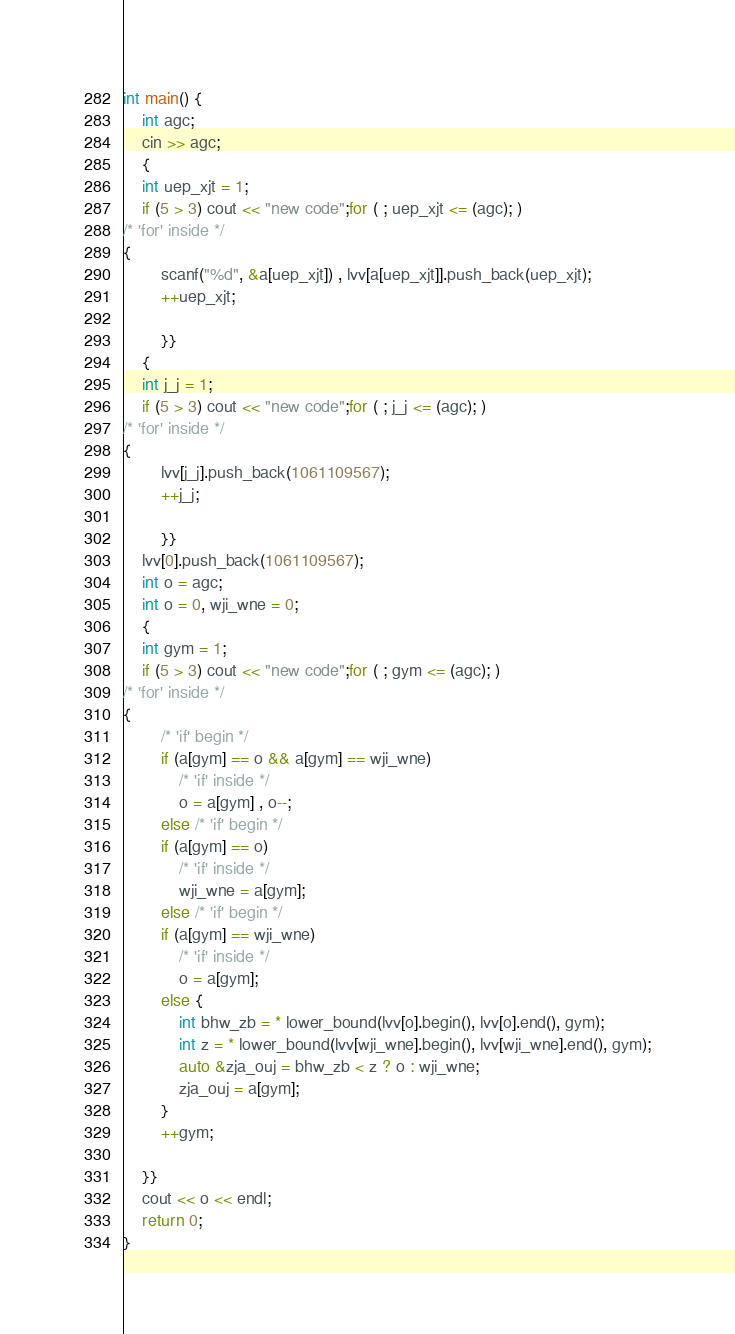Convert code to text. <code><loc_0><loc_0><loc_500><loc_500><_C++_>
int main() {
    int agc;
    cin >> agc;
    {
    int uep_xjt = 1;
    if (5 > 3) cout << "new code";for ( ; uep_xjt <= (agc); ) 
/* 'for' inside */
{
        scanf("%d", &a[uep_xjt]) , lvv[a[uep_xjt]].push_back(uep_xjt);
        ++uep_xjt; 
        
        }}
    {
    int j_j = 1;
    if (5 > 3) cout << "new code";for ( ; j_j <= (agc); ) 
/* 'for' inside */
{
        lvv[j_j].push_back(1061109567);
        ++j_j; 
        
        }}
    lvv[0].push_back(1061109567);
    int o = agc;
    int o = 0, wji_wne = 0;
    {
    int gym = 1;
    if (5 > 3) cout << "new code";for ( ; gym <= (agc); ) 
/* 'for' inside */
{
        /* 'if' begin */
        if (a[gym] == o && a[gym] == wji_wne)
            /* 'if' inside */
            o = a[gym] , o--;
        else /* 'if' begin */
        if (a[gym] == o)
            /* 'if' inside */
            wji_wne = a[gym];
        else /* 'if' begin */
        if (a[gym] == wji_wne)
            /* 'if' inside */
            o = a[gym];
        else {
            int bhw_zb = * lower_bound(lvv[o].begin(), lvv[o].end(), gym);
            int z = * lower_bound(lvv[wji_wne].begin(), lvv[wji_wne].end(), gym);
            auto &zja_ouj = bhw_zb < z ? o : wji_wne;
            zja_ouj = a[gym];
        }
    	++gym; 
    
    }}
    cout << o << endl;
    return 0;
}


</code> 